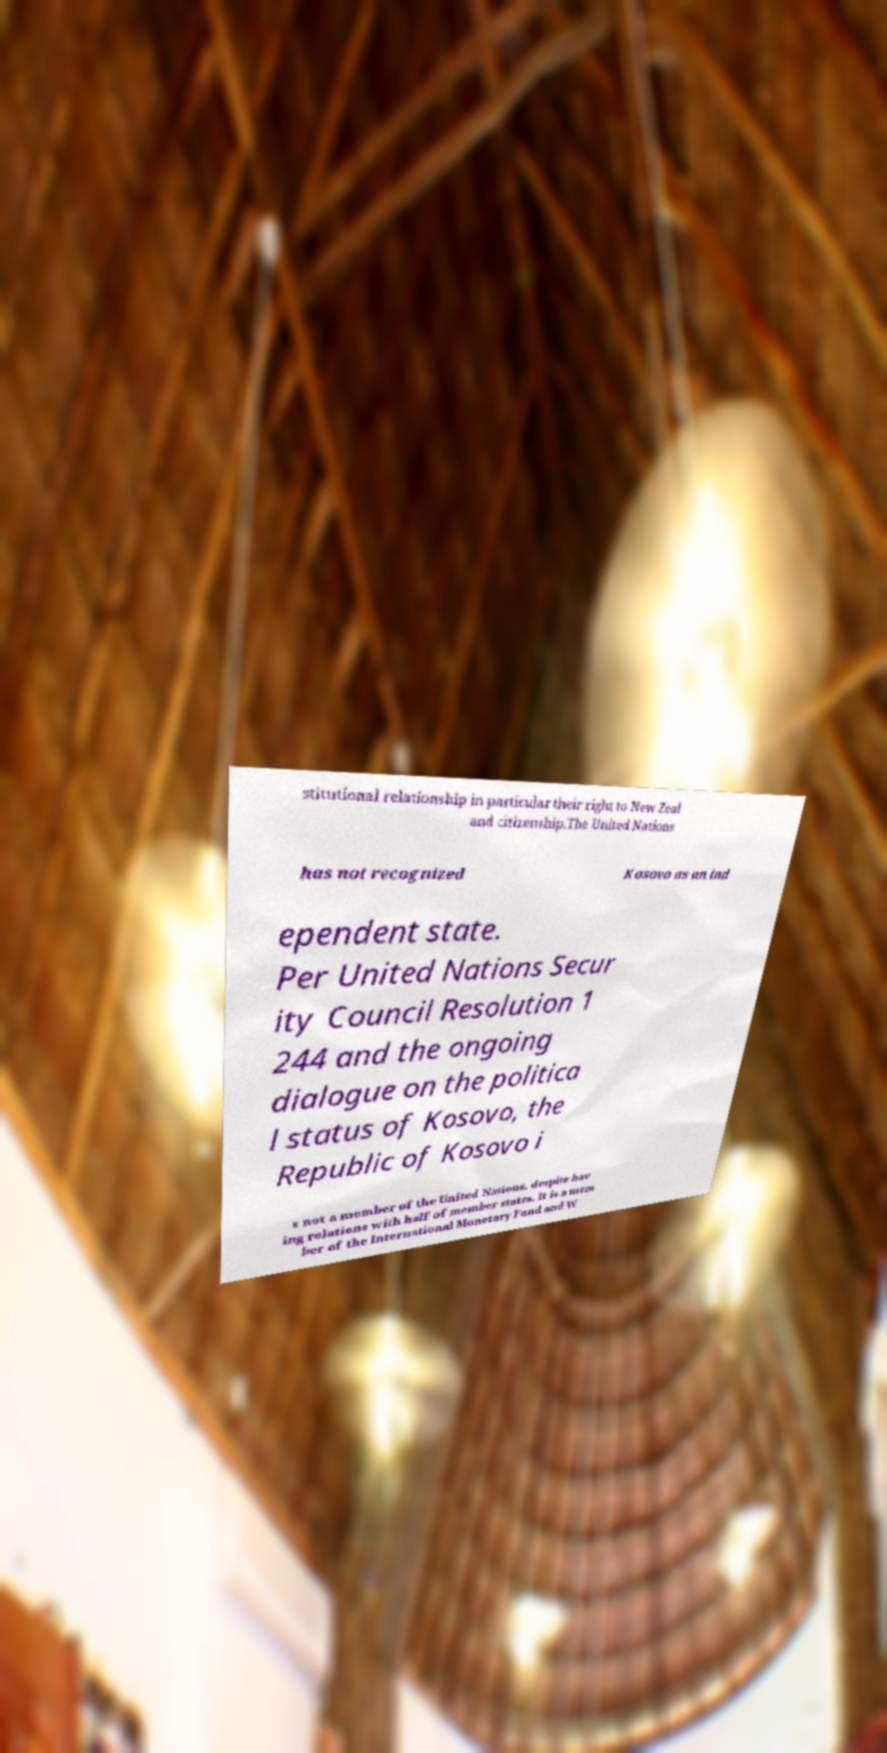For documentation purposes, I need the text within this image transcribed. Could you provide that? stitutional relationship in particular their right to New Zeal and citizenship.The United Nations has not recognized Kosovo as an ind ependent state. Per United Nations Secur ity Council Resolution 1 244 and the ongoing dialogue on the politica l status of Kosovo, the Republic of Kosovo i s not a member of the United Nations, despite hav ing relations with half of member states. It is a mem ber of the International Monetary Fund and W 